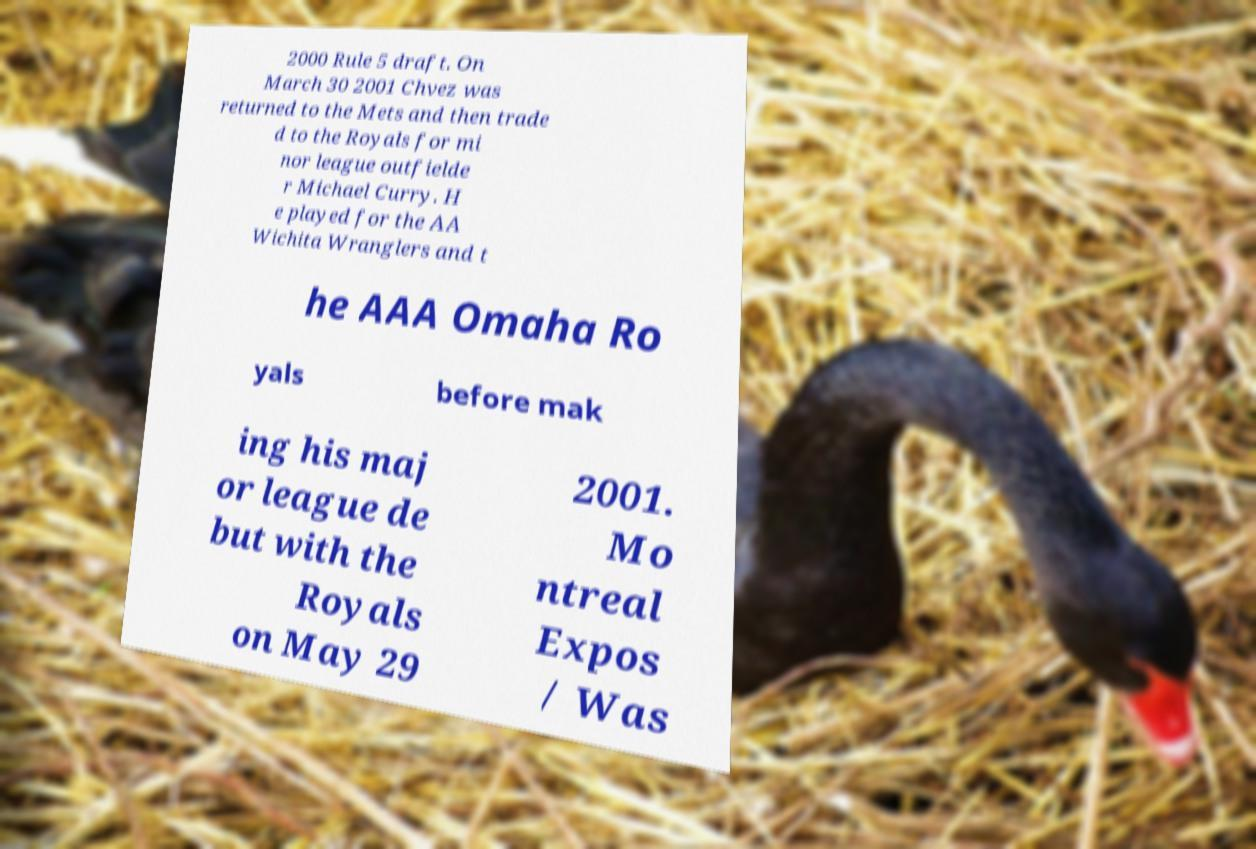What messages or text are displayed in this image? I need them in a readable, typed format. 2000 Rule 5 draft. On March 30 2001 Chvez was returned to the Mets and then trade d to the Royals for mi nor league outfielde r Michael Curry. H e played for the AA Wichita Wranglers and t he AAA Omaha Ro yals before mak ing his maj or league de but with the Royals on May 29 2001. Mo ntreal Expos / Was 